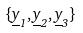<formula> <loc_0><loc_0><loc_500><loc_500>\{ \underline { y } _ { 1 } , \underline { y } _ { 2 } , \underline { y } _ { 3 } \}</formula> 